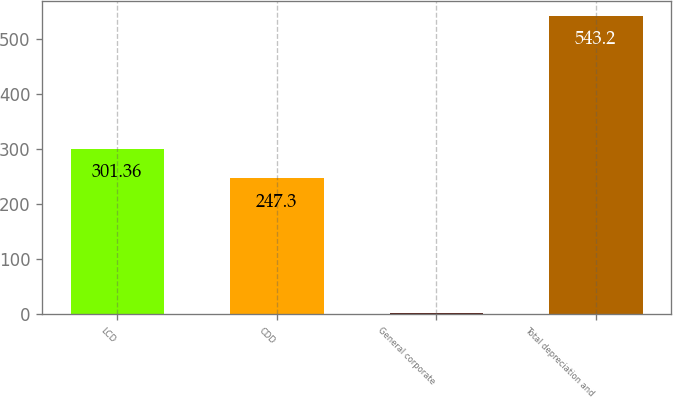Convert chart. <chart><loc_0><loc_0><loc_500><loc_500><bar_chart><fcel>LCD<fcel>CDD<fcel>General corporate<fcel>Total depreciation and<nl><fcel>301.36<fcel>247.3<fcel>2.6<fcel>543.2<nl></chart> 